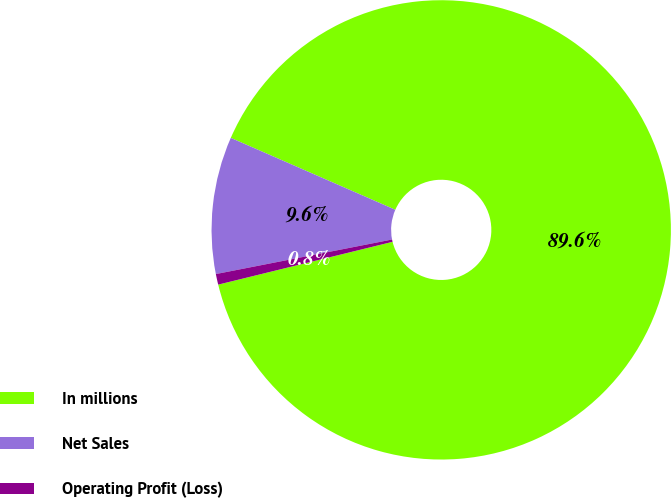<chart> <loc_0><loc_0><loc_500><loc_500><pie_chart><fcel>In millions<fcel>Net Sales<fcel>Operating Profit (Loss)<nl><fcel>89.61%<fcel>9.64%<fcel>0.75%<nl></chart> 